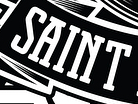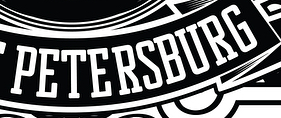Read the text from these images in sequence, separated by a semicolon. SAINT; PETERSBURG 